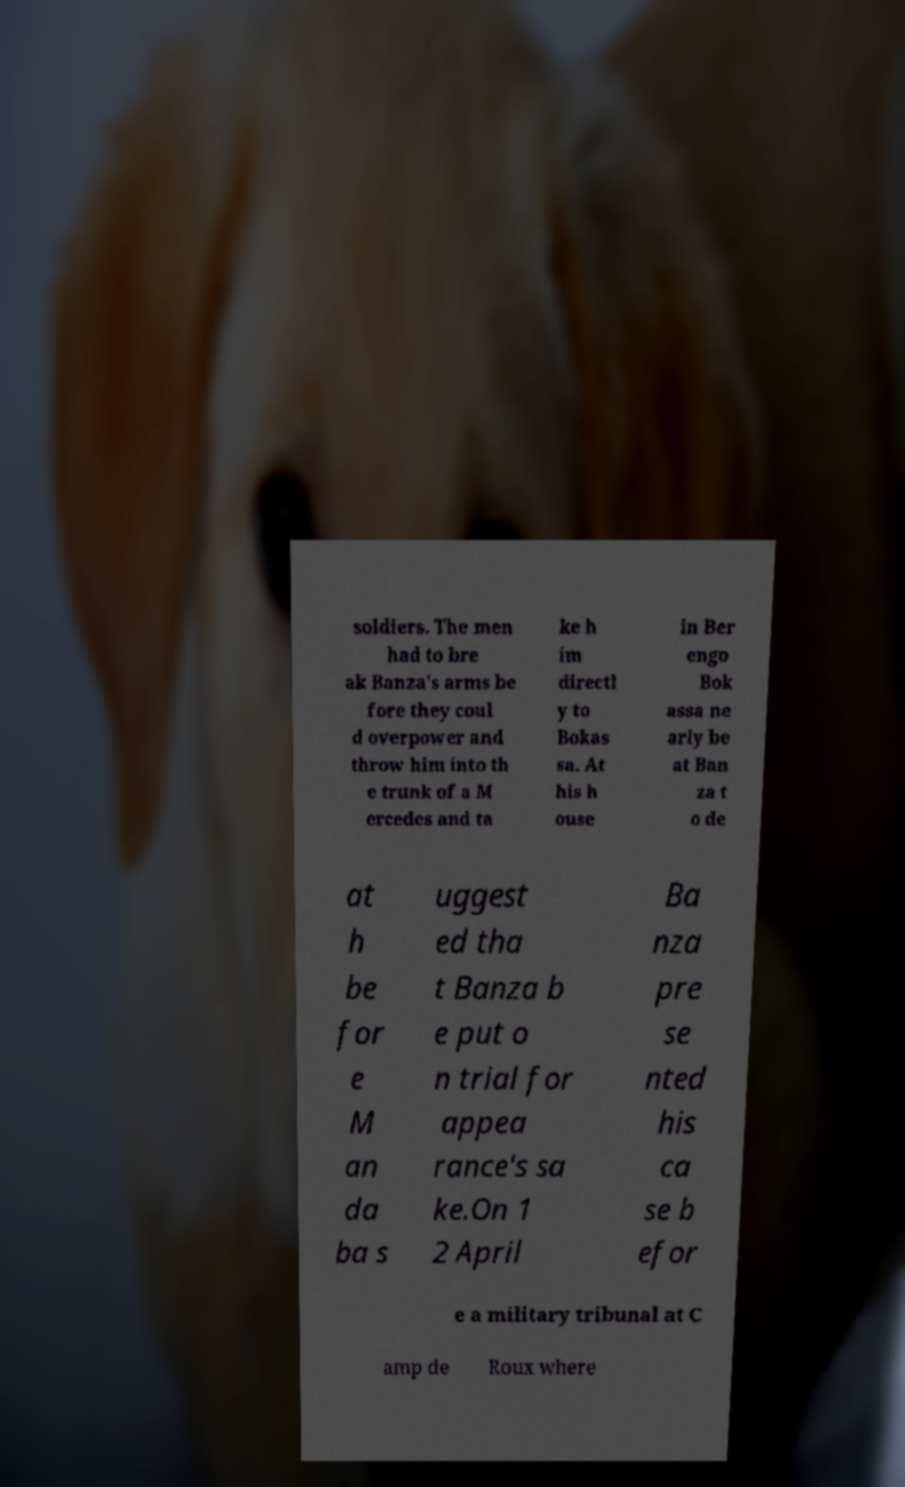What messages or text are displayed in this image? I need them in a readable, typed format. soldiers. The men had to bre ak Banza's arms be fore they coul d overpower and throw him into th e trunk of a M ercedes and ta ke h im directl y to Bokas sa. At his h ouse in Ber engo Bok assa ne arly be at Ban za t o de at h be for e M an da ba s uggest ed tha t Banza b e put o n trial for appea rance's sa ke.On 1 2 April Ba nza pre se nted his ca se b efor e a military tribunal at C amp de Roux where 